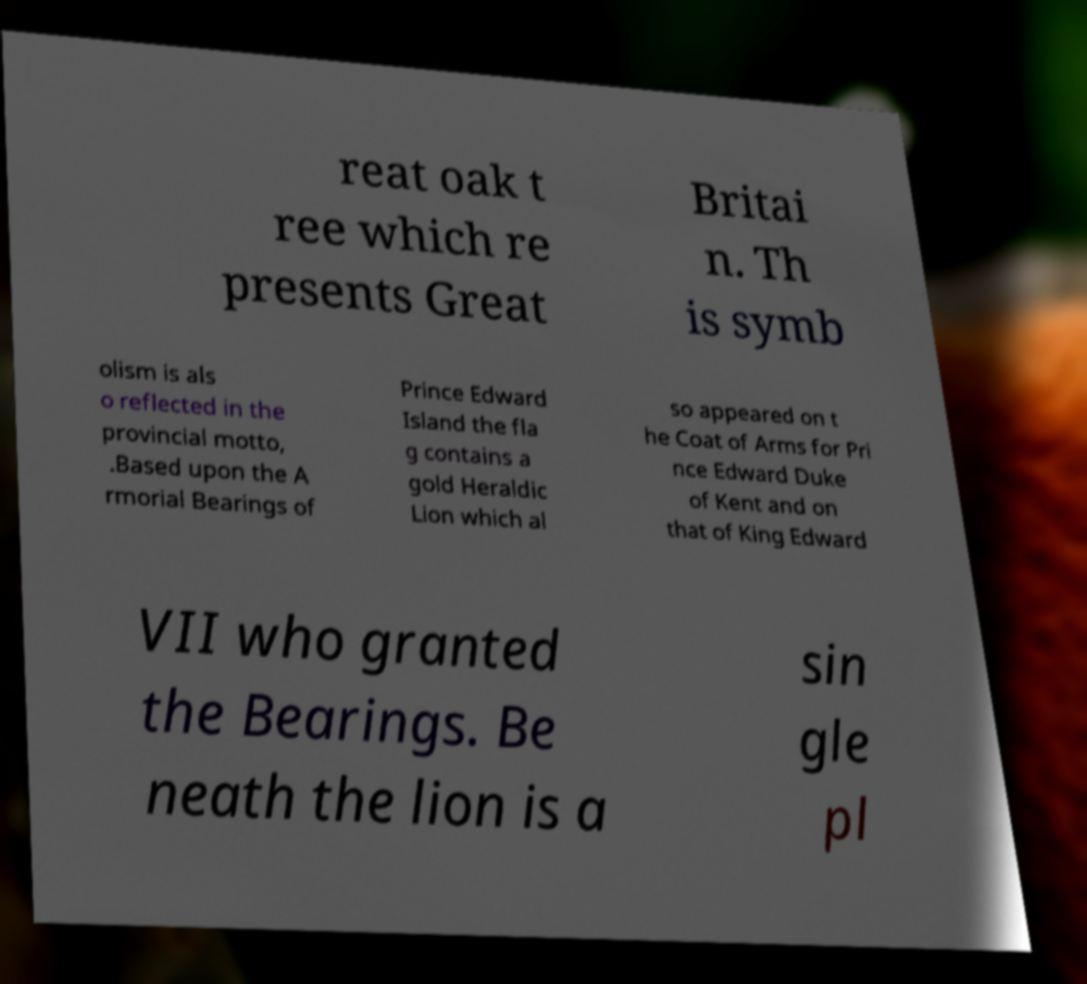For documentation purposes, I need the text within this image transcribed. Could you provide that? reat oak t ree which re presents Great Britai n. Th is symb olism is als o reflected in the provincial motto, .Based upon the A rmorial Bearings of Prince Edward Island the fla g contains a gold Heraldic Lion which al so appeared on t he Coat of Arms for Pri nce Edward Duke of Kent and on that of King Edward VII who granted the Bearings. Be neath the lion is a sin gle pl 